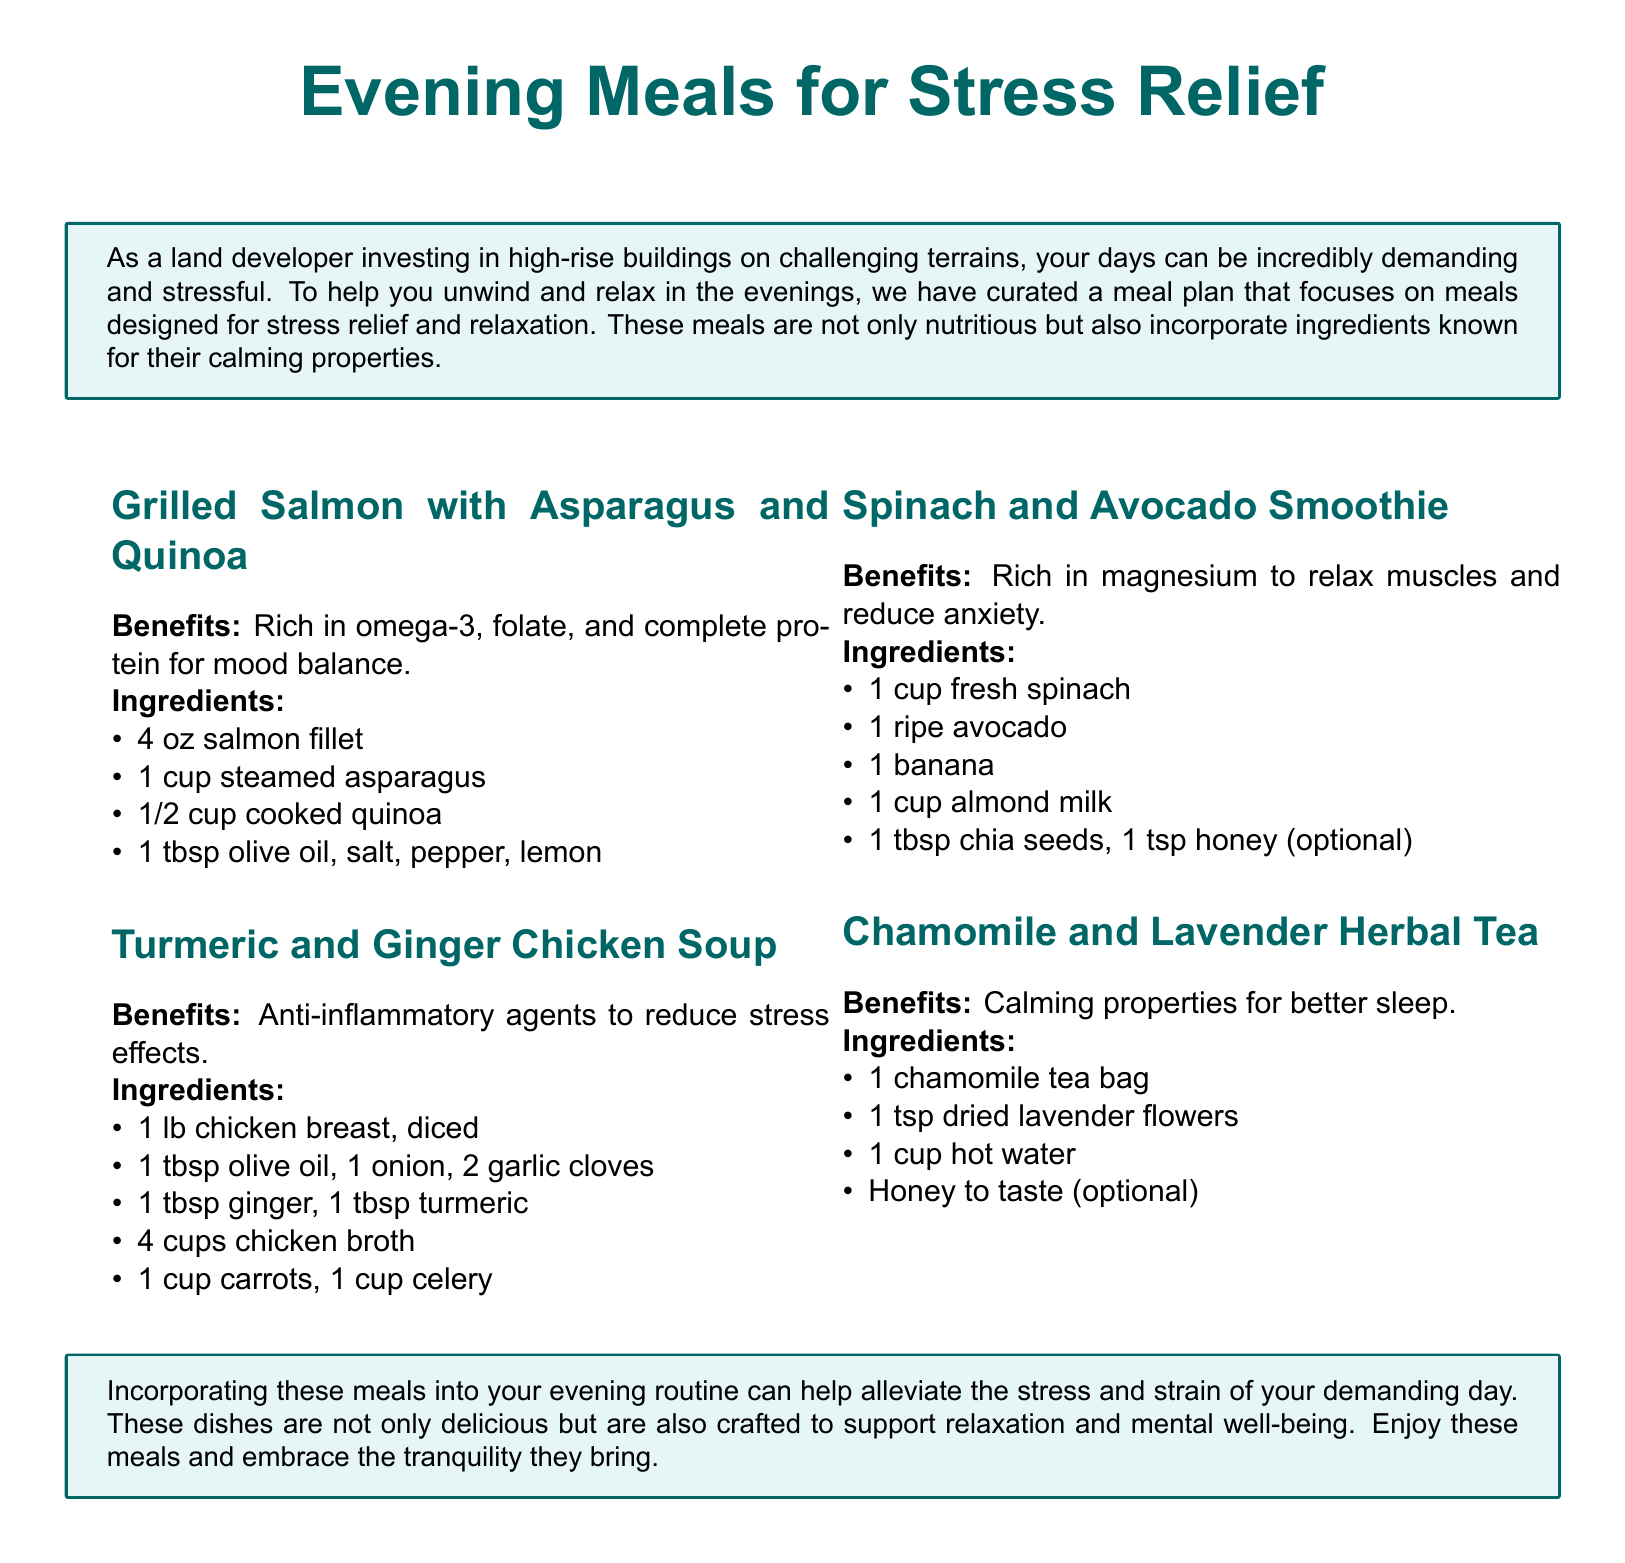What is the first meal mentioned in the document? The first meal listed in the document is "Grilled Salmon with Asparagus and Quinoa."
Answer: Grilled Salmon with Asparagus and Quinoa What ingredient is listed for the Turmeric and Ginger Chicken Soup? The ingredients for this soup include "chicken breast, onion, garlic cloves, ginger, turmeric, chicken broth, carrots, celery."
Answer: 1 lb chicken breast, diced How many cups of almond milk are required for the Spinach and Avocado Smoothie? The smoothie requires "1 cup almond milk."
Answer: 1 cup What calming drink is mentioned in the meal plan? The meal plan includes "Chamomile and Lavender Herbal Tea."
Answer: Chamomile and Lavender Herbal Tea What nutrient is emphasized in the Grilled Salmon meal? The Grilled Salmon meal is rich in "omega-3."
Answer: omega-3 Why are these meals important according to the document? They are crafted to "support relaxation and mental well-being."
Answer: support relaxation and mental well-being How many ingredients are needed for the Spinach and Avocado Smoothie? The recipe has "six" ingredients listed.
Answer: six What is the optional sweetener for Chamomile and Lavender Herbal Tea? The optional sweetener mentioned is "Honey."
Answer: Honey 